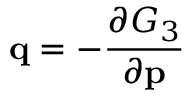Convert formula to latex. <formula><loc_0><loc_0><loc_500><loc_500>q = - { \frac { \partial G _ { 3 } } { \partial p } }</formula> 